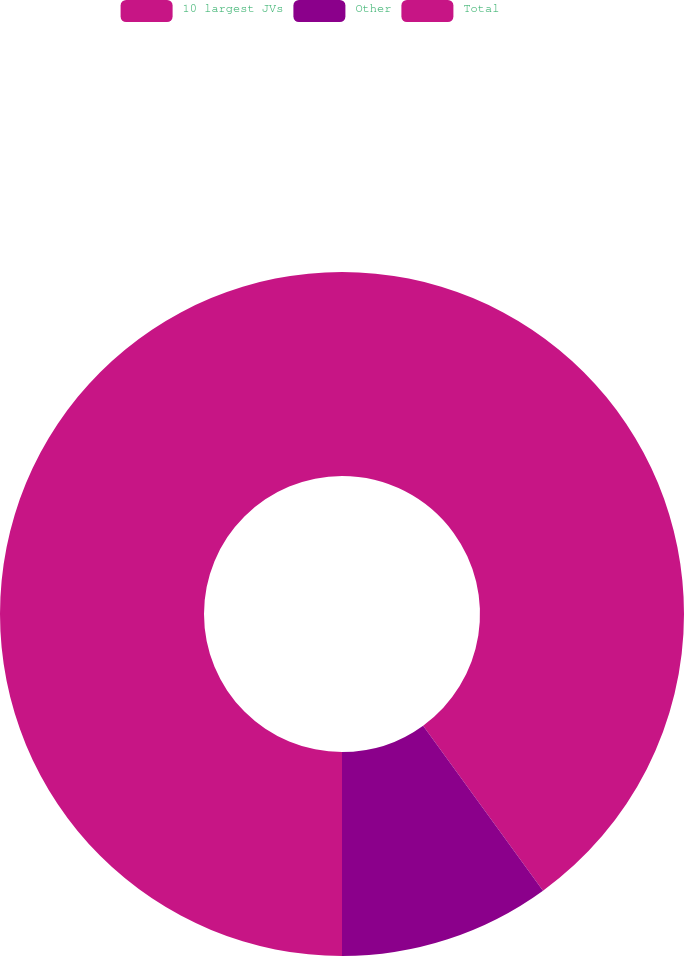<chart> <loc_0><loc_0><loc_500><loc_500><pie_chart><fcel>10 largest JVs<fcel>Other<fcel>Total<nl><fcel>40.0%<fcel>10.0%<fcel>50.0%<nl></chart> 